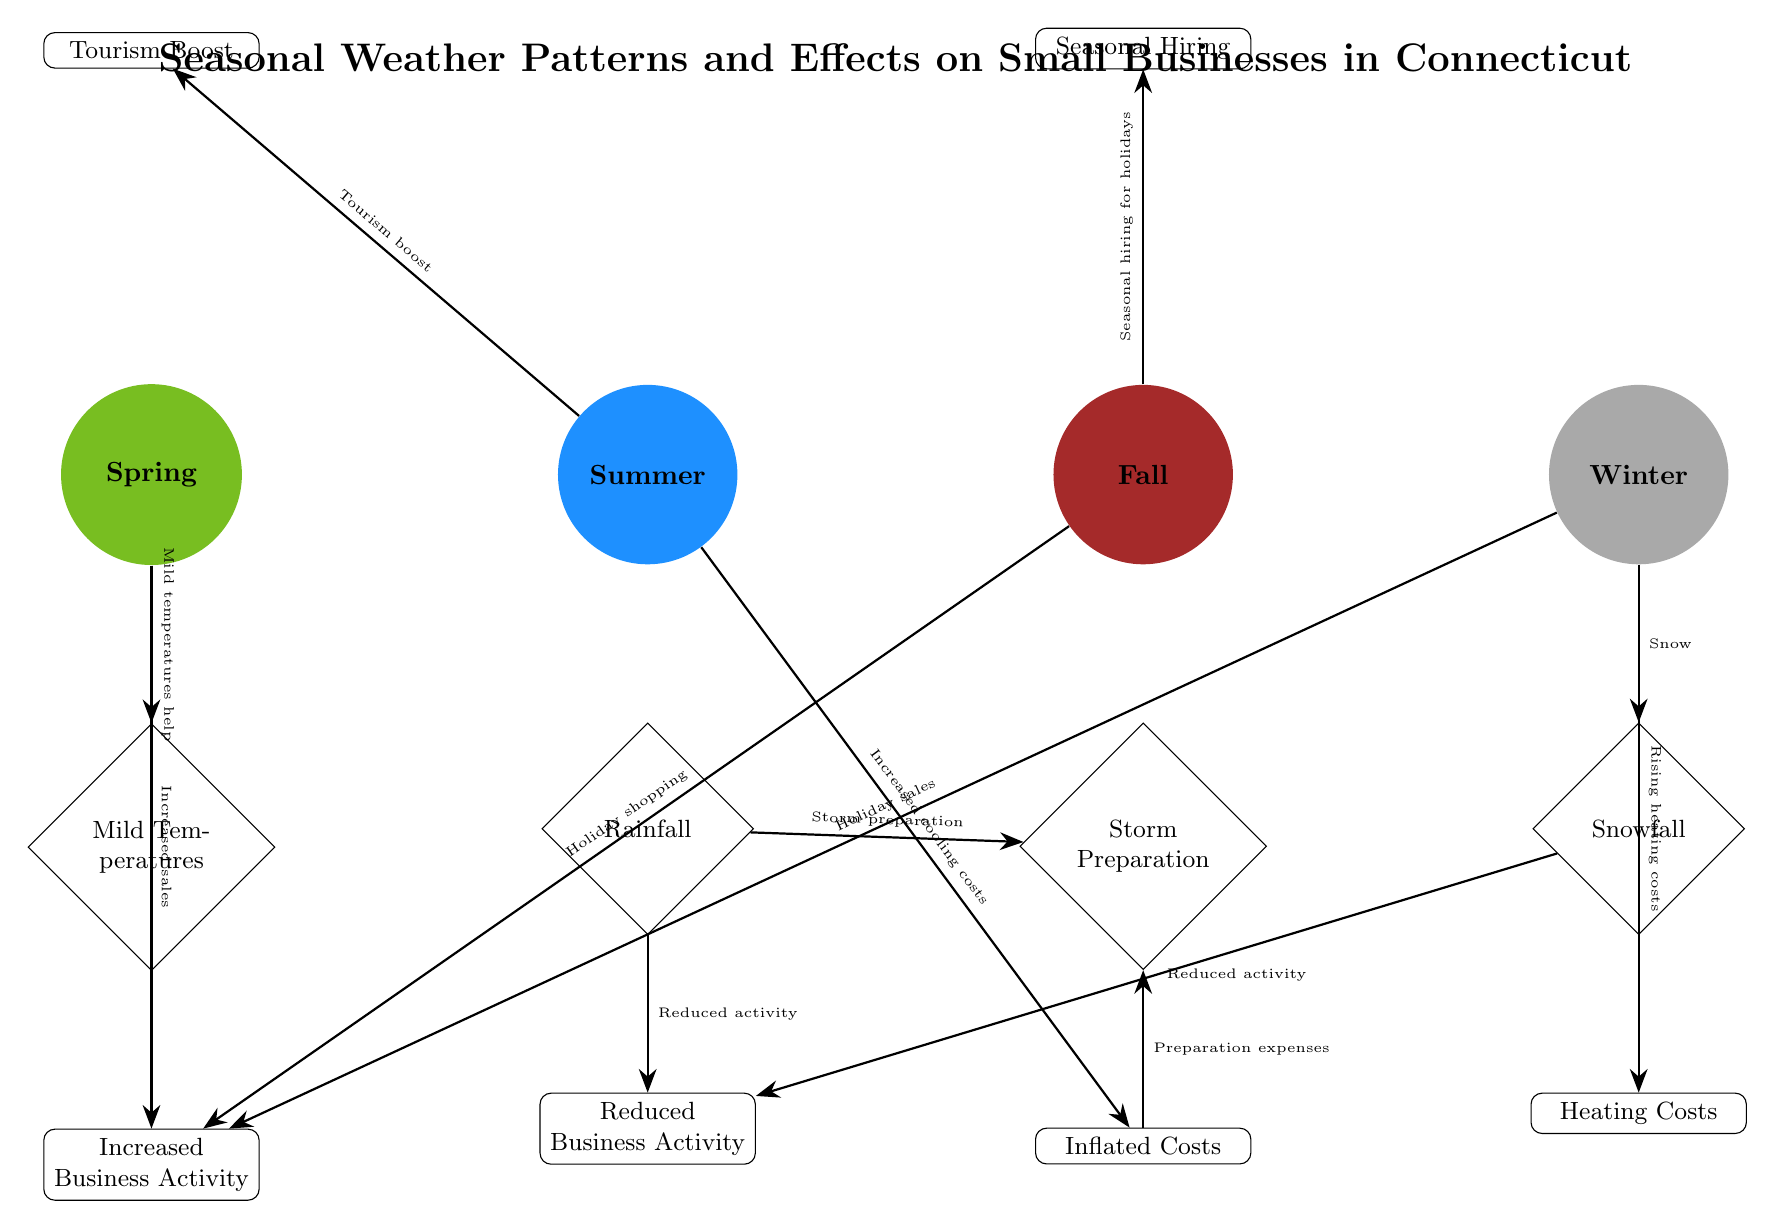What are the colors representing each season? The diagram uses specific colors for each season: Spring is represented by green, Summer by blue, Fall by brown, and Winter by gray.
Answer: green, blue, brown, gray What is the effect of mild temperatures on small businesses? According to the diagram, mild temperatures help increase business activity, which is directly linked from the mild temperatures node.
Answer: Increased Business Activity How many weather conditions are depicted in the diagram? The diagram shows four weather conditions: Mild Temperatures, Rainfall, Storm Preparation, and Snowfall. Counting each weather node gives a total of four.
Answer: 4 What is the relationship between snowfall and reduced business activity? The diagram shows a direct connection from the snowfall node to the reduced activity node, indicating that snowfall leads to reduced business activity.
Answer: Reduced Activity What do businesses experience during summer due to weather conditions? The diagram indicates that summer conditions cause a tourism boost and also mention increased cooling costs, which affects small businesses during this season.
Answer: Tourism Boost, Increased Cooling Costs What impacts seasonally hiring in small businesses? The diagram links autumn to seasonal hiring, indicating that preparations for the holiday season stimulate hiring activities for small businesses.
Answer: Seasonal Hiring How does storm preparation affect costs for businesses? The diagram demonstrates that storm preparation leads to inflated costs for small businesses as they prepare for adverse weather conditions that can disrupt their operations.
Answer: Inflated Costs What happens to small businesses when there is rainfall? Rainfall as depicted in the diagram results in reduced business activity and the need for storm preparation, indicating adverse effects on business operations.
Answer: Reduced Business Activity What is a common impact of both winter weather and snowfall? Both winter weather and snowfall lead to reduced business activity as shown in the diagram, highlighting that extreme winter conditions can significantly slow down operations.
Answer: Reduced Activity 